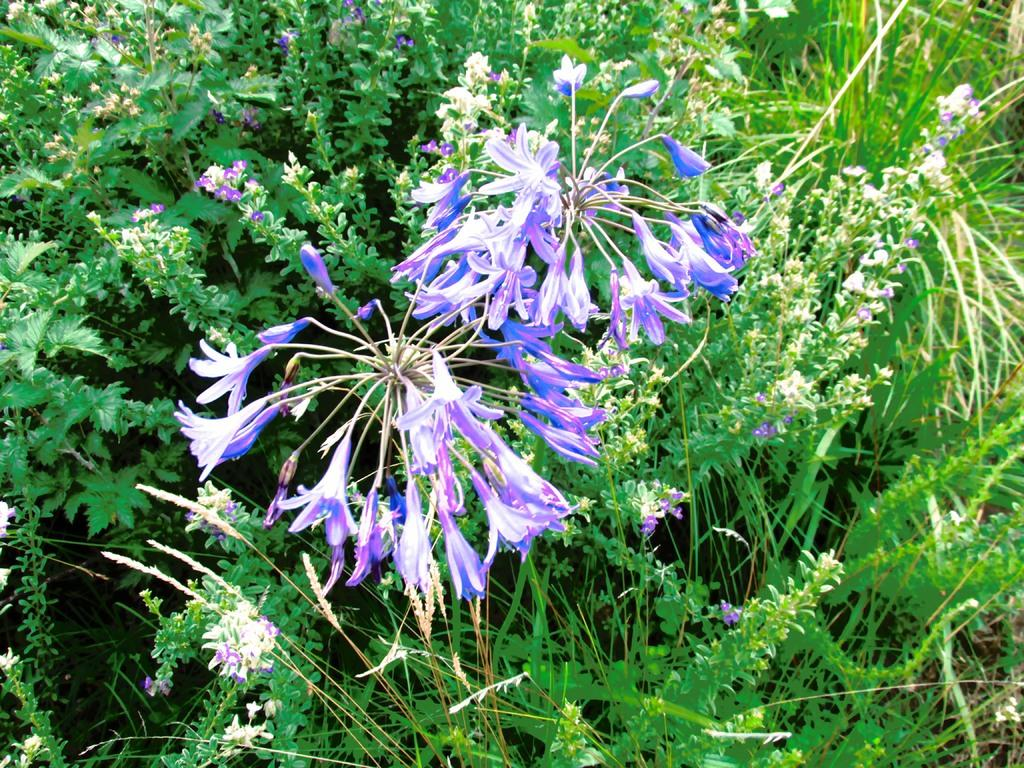What type of vegetation can be seen in the image? There is grass and trees in the image. Are there any other plants visible in the image? Yes, there are colorful flowers in the image. What is the weather like in the image? The image is sunny. What type of lace can be seen on the flowers in the image? There is no lace present on the flowers in the image. What muscle is being exercised by the trees in the image? Trees do not have muscles, and therefore this question is not applicable to the image. 